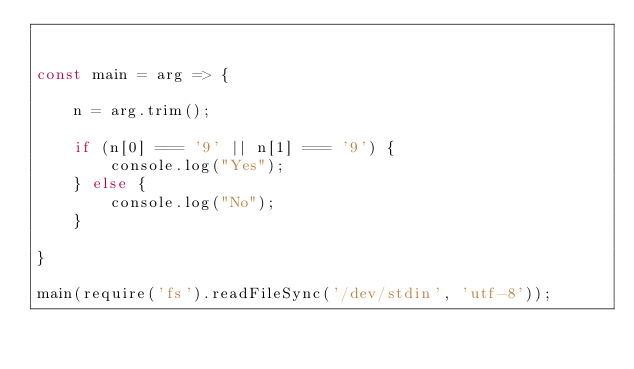<code> <loc_0><loc_0><loc_500><loc_500><_JavaScript_>

const main = arg => {

    n = arg.trim();

    if (n[0] === '9' || n[1] === '9') {
        console.log("Yes");
    } else {
        console.log("No");
    }

}

main(require('fs').readFileSync('/dev/stdin', 'utf-8'));</code> 